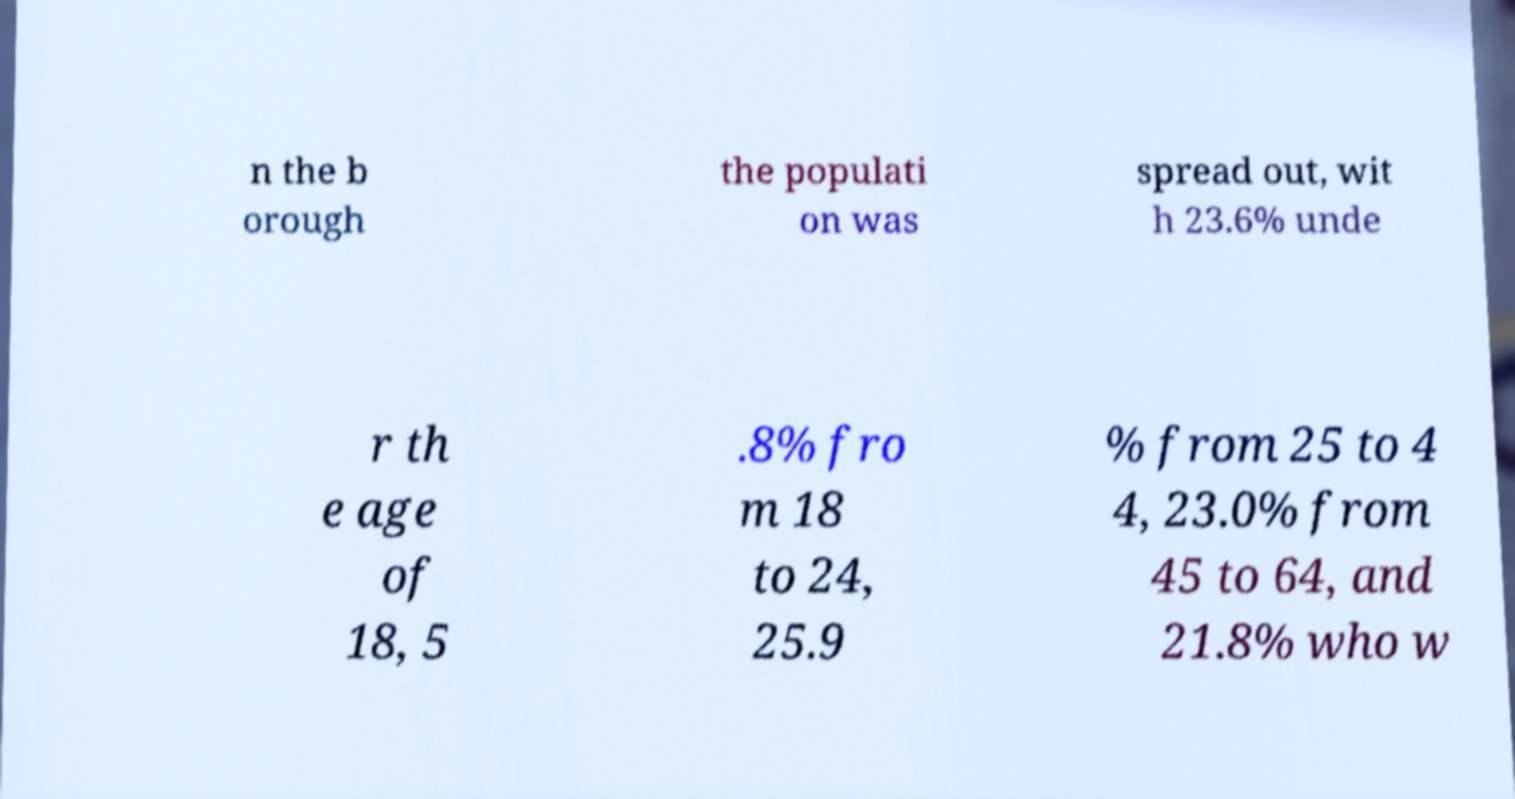Could you assist in decoding the text presented in this image and type it out clearly? n the b orough the populati on was spread out, wit h 23.6% unde r th e age of 18, 5 .8% fro m 18 to 24, 25.9 % from 25 to 4 4, 23.0% from 45 to 64, and 21.8% who w 